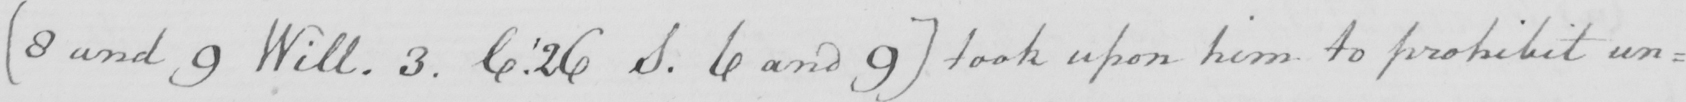Can you read and transcribe this handwriting? [ 8 and 9 Will . 3 . C . ' 26 S . 6 and 9 ]  took upon him to prohibit un= 